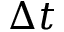Convert formula to latex. <formula><loc_0><loc_0><loc_500><loc_500>\Delta t</formula> 